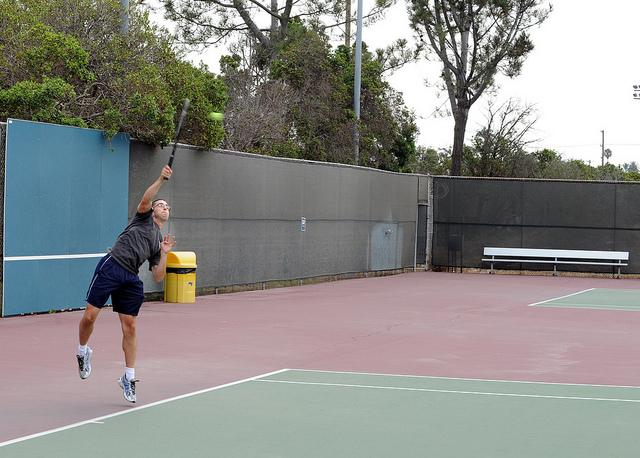Why is his arm raised so high?

Choices:
A) is tired
B) hit ball
C) wants attention
D) is falling hit ball 